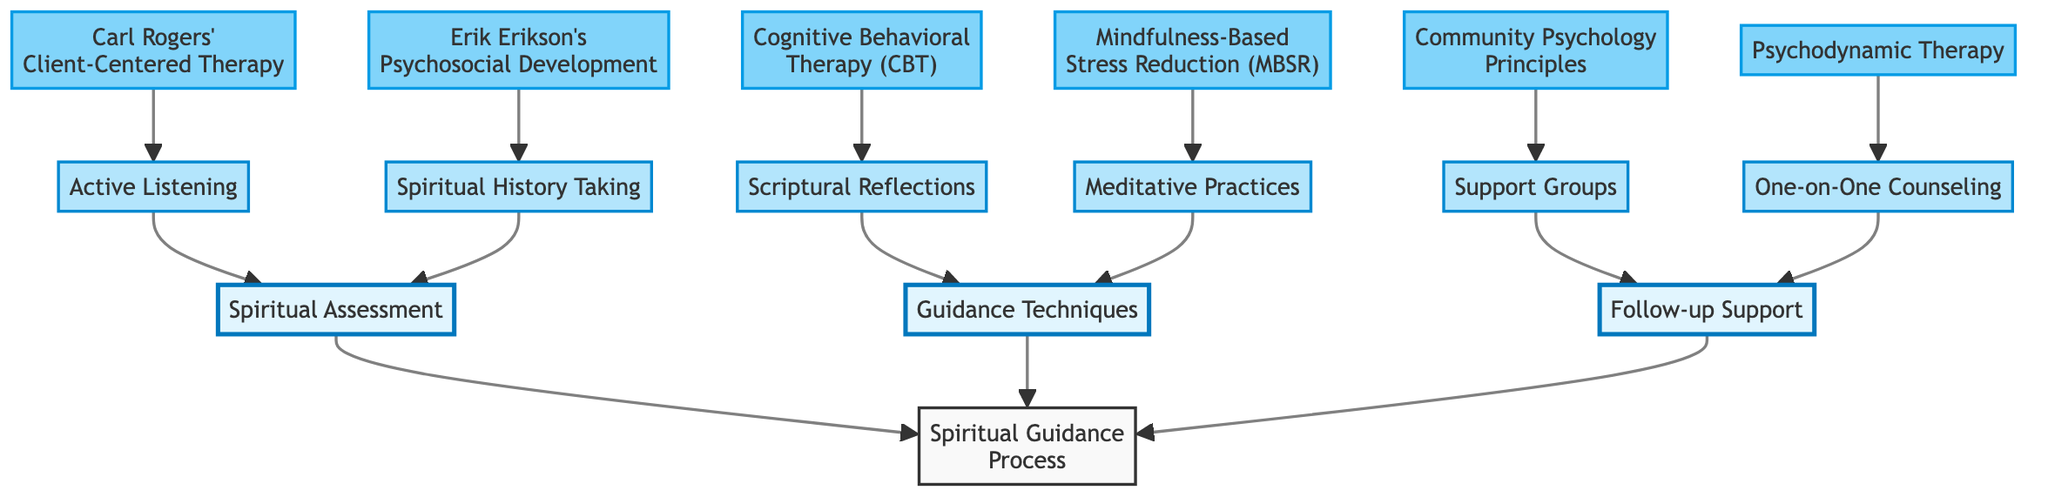What are the three main categories in the diagram? The diagram contains three main categories: "Spiritual Assessment," "Guidance Techniques," and "Follow-up Support." These categories are the highest-level nodes that group the other techniques and frameworks.
Answer: Spiritual Assessment, Guidance Techniques, Follow-up Support How many guidance techniques are listed in the diagram? The diagram lists four guidance techniques: "Meditative Practices," "Scriptural Reflections," "Active Listening," and "Spiritual History Taking." These are sub-nodes under the "Guidance Techniques" category.
Answer: 4 Which psychological framework corresponds to Active Listening? Active Listening corresponds to "Carl Rogers' Client-Centered Therapy," which is listed as a child node under Active Listening in the diagram.
Answer: Carl Rogers' Client-Centered Therapy What type of support does One-on-One Counseling provide? One-on-One Counseling provides "Psychodynamic Therapy," which is specifically a psychological framework utilized in the follow-up support category.
Answer: Psychodynamic Therapy What are the psychological principles associated with Support Groups? Support Groups are associated with "Community Psychology Principles" as indicated by the connection to the corresponding framework in the follow-up support section.
Answer: Community Psychology Principles How many psychological frameworks are utilized in the spiritual guidance process? The diagram outlines six psychological frameworks: "Carl Rogers' Client-Centered Therapy," "Erik Erikson's Psychosocial Development," "Mindfulness-Based Stress Reduction," "Cognitive Behavioral Therapy," "Community Psychology Principles," and "Psychodynamic Therapy." These frameworks connect various guidance techniques and follow-up support strategies.
Answer: 6 What is the relationship between Scriptural Reflections and its corresponding psychological framework? Scriptural Reflections is connected to "Cognitive Behavioral Therapy," meaning that this guidance technique is informed by or uses principles from CBT in the counseling process.
Answer: Cognitive Behavioral Therapy What two techniques fall under the Guidance category? The Guidance category includes "Meditative Practices" and "Scriptural Reflections," which are the specific techniques categorized under guidance in the diagram.
Answer: Meditative Practices and Scriptural Reflections What are the types of follow-up support mentioned in the diagram? The types of follow-up support mentioned are "Support Groups" and "One-on-One Counseling," both of which provide different forms of support in the spiritual guidance process.
Answer: Support Groups, One-on-One Counseling How is "Spiritual History Taking" categorized in the diagram? "Spiritual History Taking" is categorized under "Spiritual Assessment," which indicates that it is part of the initial evaluation process in spiritual guidance.
Answer: Spiritual Assessment 